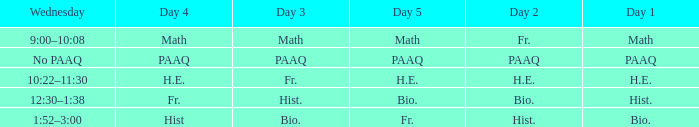What is the day 1 when the day 3 is math? Math. 